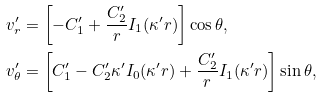Convert formula to latex. <formula><loc_0><loc_0><loc_500><loc_500>v ^ { \prime } _ { r } & = \left [ - C _ { 1 } ^ { \prime } + \frac { C _ { 2 } ^ { \prime } } { r } I _ { 1 } ( \kappa ^ { \prime } r ) \right ] \cos \theta , \\ v ^ { \prime } _ { \theta } & = \left [ C _ { 1 } ^ { \prime } - C _ { 2 } ^ { \prime } \kappa ^ { \prime } I _ { 0 } ( \kappa ^ { \prime } r ) + \frac { C _ { 2 } ^ { \prime } } { r } I _ { 1 } ( \kappa ^ { \prime } r ) \right ] \sin \theta ,</formula> 